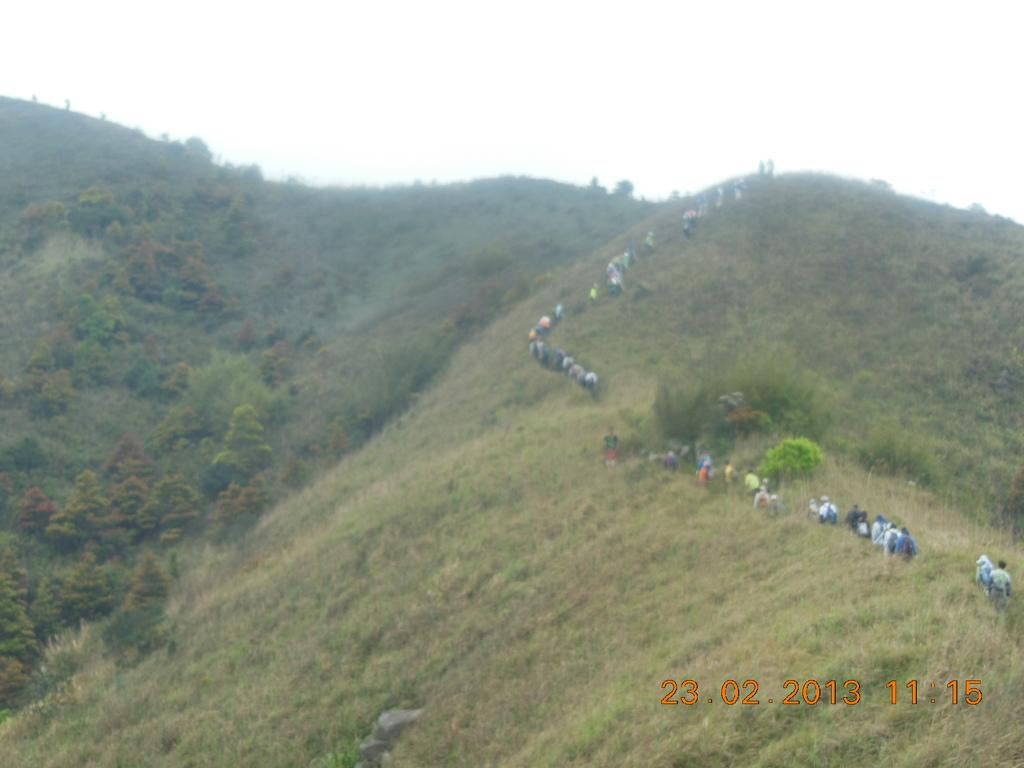What type of vegetation can be seen in the image? There are trees, plants, and grass visible in the image. What are the people in the image doing? The people in the image are walking on a mountain. What is visible in the background of the image? There is a sky visible in the background of the image. What type of substance is being used by the people walking on the mountain to achieve a better grip? There is no indication in the image of any substance being used by the people walking on the mountain. How many waves can be seen crashing against the mountain in the image? There are no waves present in the image; it features people walking on a mountain with vegetation and a visible sky. 